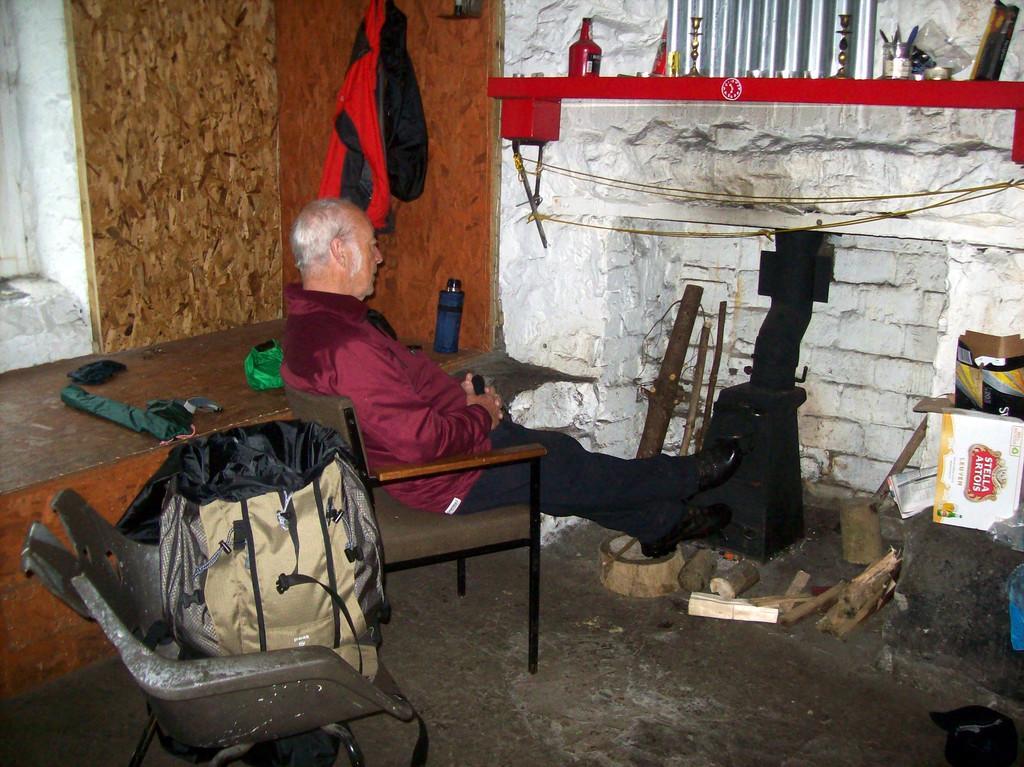In one or two sentences, can you explain what this image depicts? The person is sitting in a chair. There is a table. There is a umbrella ,some cloth on a table. In the background we can see wall,bottle and roof Shield. 